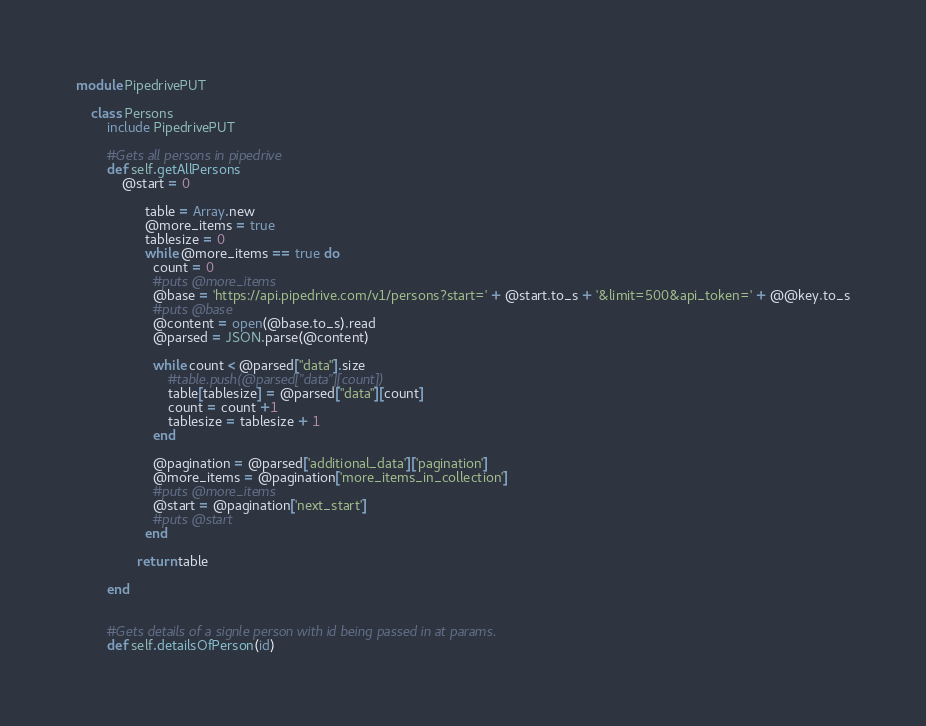<code> <loc_0><loc_0><loc_500><loc_500><_Ruby_>module PipedrivePUT

	class Persons
		include PipedrivePUT

		#Gets all persons in pipedrive
		def self.getAllPersons
			@start = 0
			  
				  table = Array.new
				  @more_items = true
				  tablesize = 0
				  while @more_items == true do
					count = 0
					#puts @more_items
					@base = 'https://api.pipedrive.com/v1/persons?start=' + @start.to_s + '&limit=500&api_token=' + @@key.to_s
					#puts @base
					@content = open(@base.to_s).read
					@parsed = JSON.parse(@content)

					while count < @parsed["data"].size
						#table.push(@parsed["data"][count])
						table[tablesize] = @parsed["data"][count]
						count = count +1
						tablesize = tablesize + 1
					end

					@pagination = @parsed['additional_data']['pagination']
					@more_items = @pagination['more_items_in_collection']
					#puts @more_items
					@start = @pagination['next_start']
					#puts @start
				  end

				return table
				
		end


		#Gets details of a signle person with id being passed in at params.
		def self.detailsOfPerson(id)</code> 